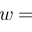<formula> <loc_0><loc_0><loc_500><loc_500>w =</formula> 